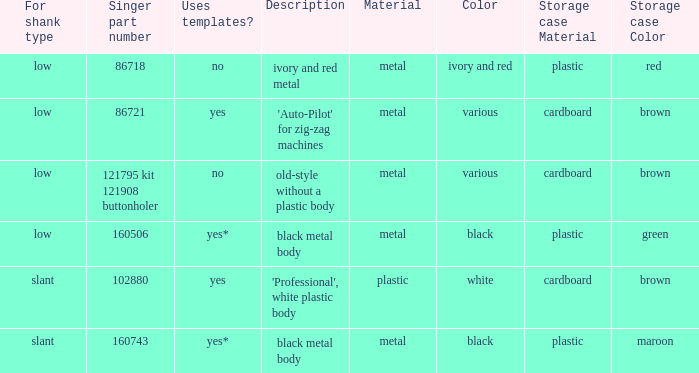What's the storage case of the buttonholer described as ivory and red metal? Red plastic box. 